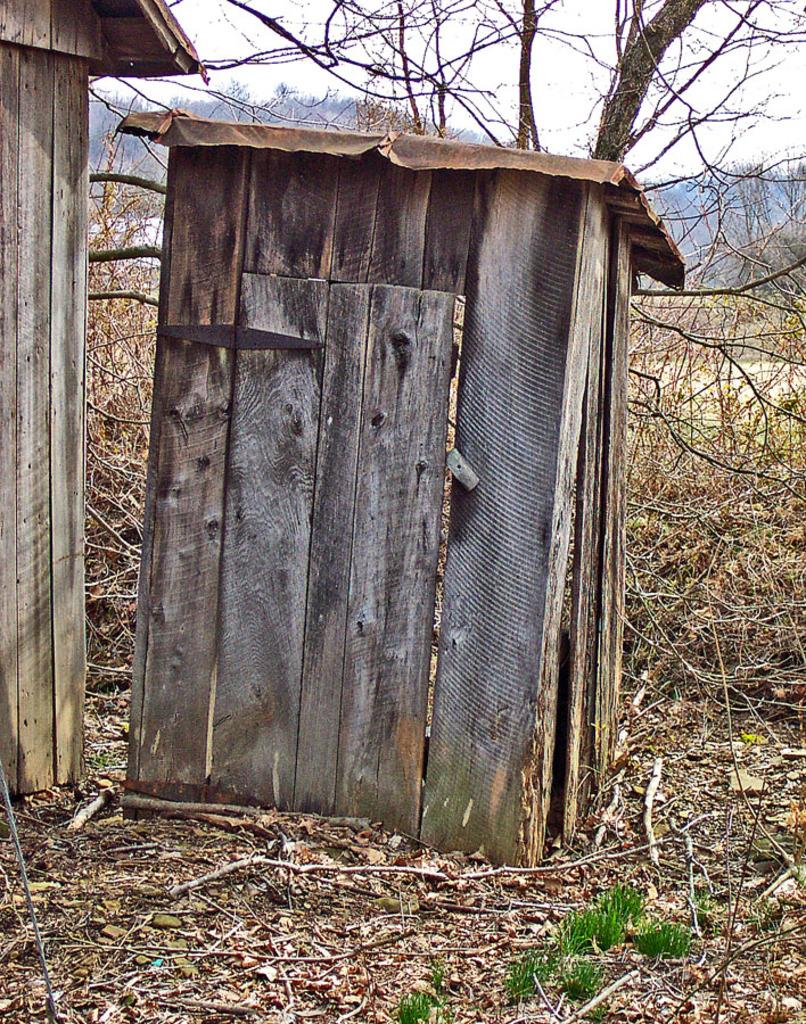What structures are located on the ground in the image? There are sheds on the ground in the image. What type of vegetation can be seen in the background of the image? There are trees visible in the background of the image. What is visible in the sky in the background of the image? The sky is visible in the background of the image. What type of slip can be seen on the sheds in the image? There is no slip present on the sheds in the image. How does the snow affect the visibility of the sheds in the image? There is no snow present in the image, so it does not affect the visibility of the sheds. 